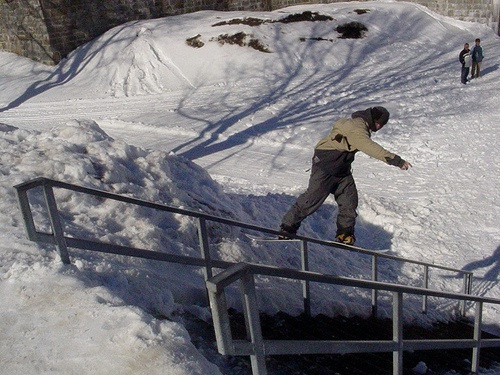Describe the objects in this image and their specific colors. I can see people in gray, black, and darkgray tones, snowboard in gray, darkgray, and black tones, people in gray, black, and darkgray tones, and people in gray, black, and darkgray tones in this image. 